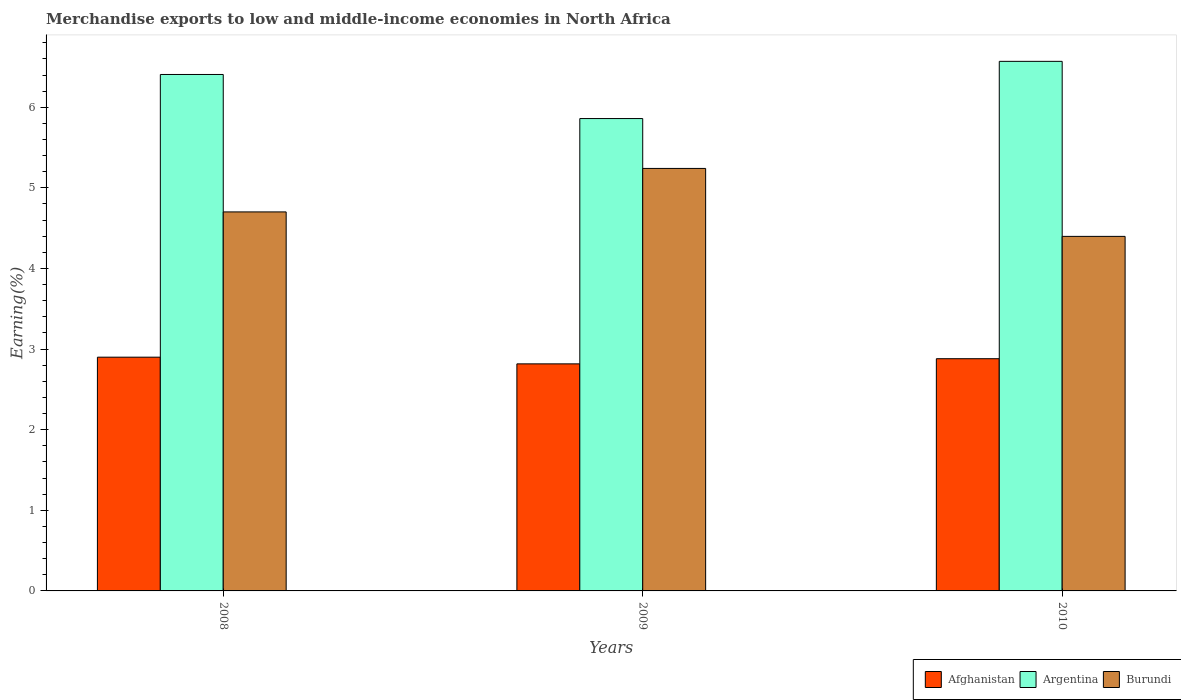How many different coloured bars are there?
Provide a succinct answer. 3. How many bars are there on the 1st tick from the left?
Provide a short and direct response. 3. How many bars are there on the 1st tick from the right?
Give a very brief answer. 3. What is the label of the 1st group of bars from the left?
Offer a terse response. 2008. What is the percentage of amount earned from merchandise exports in Afghanistan in 2009?
Ensure brevity in your answer.  2.82. Across all years, what is the maximum percentage of amount earned from merchandise exports in Afghanistan?
Keep it short and to the point. 2.9. Across all years, what is the minimum percentage of amount earned from merchandise exports in Afghanistan?
Give a very brief answer. 2.82. In which year was the percentage of amount earned from merchandise exports in Burundi minimum?
Your answer should be compact. 2010. What is the total percentage of amount earned from merchandise exports in Afghanistan in the graph?
Give a very brief answer. 8.6. What is the difference between the percentage of amount earned from merchandise exports in Afghanistan in 2008 and that in 2009?
Offer a very short reply. 0.08. What is the difference between the percentage of amount earned from merchandise exports in Burundi in 2008 and the percentage of amount earned from merchandise exports in Argentina in 2009?
Your answer should be very brief. -1.16. What is the average percentage of amount earned from merchandise exports in Burundi per year?
Ensure brevity in your answer.  4.78. In the year 2008, what is the difference between the percentage of amount earned from merchandise exports in Argentina and percentage of amount earned from merchandise exports in Burundi?
Offer a very short reply. 1.7. In how many years, is the percentage of amount earned from merchandise exports in Afghanistan greater than 5.4 %?
Make the answer very short. 0. What is the ratio of the percentage of amount earned from merchandise exports in Argentina in 2008 to that in 2009?
Keep it short and to the point. 1.09. Is the percentage of amount earned from merchandise exports in Afghanistan in 2008 less than that in 2010?
Your answer should be very brief. No. What is the difference between the highest and the second highest percentage of amount earned from merchandise exports in Afghanistan?
Offer a very short reply. 0.02. What is the difference between the highest and the lowest percentage of amount earned from merchandise exports in Afghanistan?
Provide a short and direct response. 0.08. In how many years, is the percentage of amount earned from merchandise exports in Afghanistan greater than the average percentage of amount earned from merchandise exports in Afghanistan taken over all years?
Make the answer very short. 2. Is the sum of the percentage of amount earned from merchandise exports in Afghanistan in 2009 and 2010 greater than the maximum percentage of amount earned from merchandise exports in Argentina across all years?
Offer a terse response. No. What does the 3rd bar from the left in 2008 represents?
Your answer should be very brief. Burundi. What does the 3rd bar from the right in 2008 represents?
Your response must be concise. Afghanistan. What is the difference between two consecutive major ticks on the Y-axis?
Your answer should be very brief. 1. Are the values on the major ticks of Y-axis written in scientific E-notation?
Provide a short and direct response. No. Does the graph contain any zero values?
Your answer should be very brief. No. Does the graph contain grids?
Make the answer very short. No. Where does the legend appear in the graph?
Your answer should be very brief. Bottom right. How many legend labels are there?
Provide a succinct answer. 3. What is the title of the graph?
Provide a short and direct response. Merchandise exports to low and middle-income economies in North Africa. What is the label or title of the X-axis?
Ensure brevity in your answer.  Years. What is the label or title of the Y-axis?
Your answer should be compact. Earning(%). What is the Earning(%) in Afghanistan in 2008?
Offer a very short reply. 2.9. What is the Earning(%) of Argentina in 2008?
Give a very brief answer. 6.41. What is the Earning(%) in Burundi in 2008?
Give a very brief answer. 4.7. What is the Earning(%) of Afghanistan in 2009?
Offer a very short reply. 2.82. What is the Earning(%) in Argentina in 2009?
Offer a very short reply. 5.86. What is the Earning(%) of Burundi in 2009?
Give a very brief answer. 5.24. What is the Earning(%) in Afghanistan in 2010?
Give a very brief answer. 2.88. What is the Earning(%) in Argentina in 2010?
Offer a very short reply. 6.57. What is the Earning(%) of Burundi in 2010?
Give a very brief answer. 4.4. Across all years, what is the maximum Earning(%) in Afghanistan?
Offer a very short reply. 2.9. Across all years, what is the maximum Earning(%) in Argentina?
Offer a terse response. 6.57. Across all years, what is the maximum Earning(%) of Burundi?
Your answer should be compact. 5.24. Across all years, what is the minimum Earning(%) of Afghanistan?
Provide a succinct answer. 2.82. Across all years, what is the minimum Earning(%) of Argentina?
Your answer should be very brief. 5.86. Across all years, what is the minimum Earning(%) in Burundi?
Your response must be concise. 4.4. What is the total Earning(%) in Afghanistan in the graph?
Offer a terse response. 8.6. What is the total Earning(%) of Argentina in the graph?
Provide a succinct answer. 18.84. What is the total Earning(%) in Burundi in the graph?
Make the answer very short. 14.34. What is the difference between the Earning(%) of Afghanistan in 2008 and that in 2009?
Your answer should be compact. 0.08. What is the difference between the Earning(%) in Argentina in 2008 and that in 2009?
Give a very brief answer. 0.55. What is the difference between the Earning(%) in Burundi in 2008 and that in 2009?
Make the answer very short. -0.54. What is the difference between the Earning(%) in Afghanistan in 2008 and that in 2010?
Offer a terse response. 0.02. What is the difference between the Earning(%) of Argentina in 2008 and that in 2010?
Ensure brevity in your answer.  -0.16. What is the difference between the Earning(%) of Burundi in 2008 and that in 2010?
Offer a terse response. 0.3. What is the difference between the Earning(%) in Afghanistan in 2009 and that in 2010?
Your answer should be very brief. -0.06. What is the difference between the Earning(%) in Argentina in 2009 and that in 2010?
Make the answer very short. -0.71. What is the difference between the Earning(%) of Burundi in 2009 and that in 2010?
Your answer should be compact. 0.84. What is the difference between the Earning(%) in Afghanistan in 2008 and the Earning(%) in Argentina in 2009?
Keep it short and to the point. -2.96. What is the difference between the Earning(%) in Afghanistan in 2008 and the Earning(%) in Burundi in 2009?
Your answer should be very brief. -2.34. What is the difference between the Earning(%) in Argentina in 2008 and the Earning(%) in Burundi in 2009?
Your answer should be very brief. 1.17. What is the difference between the Earning(%) of Afghanistan in 2008 and the Earning(%) of Argentina in 2010?
Keep it short and to the point. -3.67. What is the difference between the Earning(%) in Afghanistan in 2008 and the Earning(%) in Burundi in 2010?
Give a very brief answer. -1.5. What is the difference between the Earning(%) of Argentina in 2008 and the Earning(%) of Burundi in 2010?
Offer a terse response. 2.01. What is the difference between the Earning(%) of Afghanistan in 2009 and the Earning(%) of Argentina in 2010?
Provide a short and direct response. -3.75. What is the difference between the Earning(%) in Afghanistan in 2009 and the Earning(%) in Burundi in 2010?
Give a very brief answer. -1.58. What is the difference between the Earning(%) of Argentina in 2009 and the Earning(%) of Burundi in 2010?
Your answer should be very brief. 1.46. What is the average Earning(%) of Afghanistan per year?
Offer a terse response. 2.87. What is the average Earning(%) in Argentina per year?
Give a very brief answer. 6.28. What is the average Earning(%) in Burundi per year?
Your response must be concise. 4.78. In the year 2008, what is the difference between the Earning(%) of Afghanistan and Earning(%) of Argentina?
Your answer should be very brief. -3.51. In the year 2008, what is the difference between the Earning(%) of Afghanistan and Earning(%) of Burundi?
Make the answer very short. -1.8. In the year 2008, what is the difference between the Earning(%) of Argentina and Earning(%) of Burundi?
Your answer should be compact. 1.7. In the year 2009, what is the difference between the Earning(%) of Afghanistan and Earning(%) of Argentina?
Provide a succinct answer. -3.04. In the year 2009, what is the difference between the Earning(%) of Afghanistan and Earning(%) of Burundi?
Give a very brief answer. -2.42. In the year 2009, what is the difference between the Earning(%) of Argentina and Earning(%) of Burundi?
Your answer should be very brief. 0.62. In the year 2010, what is the difference between the Earning(%) in Afghanistan and Earning(%) in Argentina?
Ensure brevity in your answer.  -3.69. In the year 2010, what is the difference between the Earning(%) of Afghanistan and Earning(%) of Burundi?
Provide a succinct answer. -1.52. In the year 2010, what is the difference between the Earning(%) in Argentina and Earning(%) in Burundi?
Your answer should be compact. 2.17. What is the ratio of the Earning(%) in Afghanistan in 2008 to that in 2009?
Your answer should be compact. 1.03. What is the ratio of the Earning(%) of Argentina in 2008 to that in 2009?
Keep it short and to the point. 1.09. What is the ratio of the Earning(%) in Burundi in 2008 to that in 2009?
Your answer should be very brief. 0.9. What is the ratio of the Earning(%) in Afghanistan in 2008 to that in 2010?
Make the answer very short. 1.01. What is the ratio of the Earning(%) of Argentina in 2008 to that in 2010?
Ensure brevity in your answer.  0.98. What is the ratio of the Earning(%) of Burundi in 2008 to that in 2010?
Make the answer very short. 1.07. What is the ratio of the Earning(%) of Afghanistan in 2009 to that in 2010?
Make the answer very short. 0.98. What is the ratio of the Earning(%) in Argentina in 2009 to that in 2010?
Your answer should be very brief. 0.89. What is the ratio of the Earning(%) of Burundi in 2009 to that in 2010?
Your response must be concise. 1.19. What is the difference between the highest and the second highest Earning(%) of Afghanistan?
Ensure brevity in your answer.  0.02. What is the difference between the highest and the second highest Earning(%) in Argentina?
Provide a short and direct response. 0.16. What is the difference between the highest and the second highest Earning(%) in Burundi?
Your answer should be very brief. 0.54. What is the difference between the highest and the lowest Earning(%) of Afghanistan?
Provide a succinct answer. 0.08. What is the difference between the highest and the lowest Earning(%) in Argentina?
Offer a very short reply. 0.71. What is the difference between the highest and the lowest Earning(%) in Burundi?
Your answer should be compact. 0.84. 